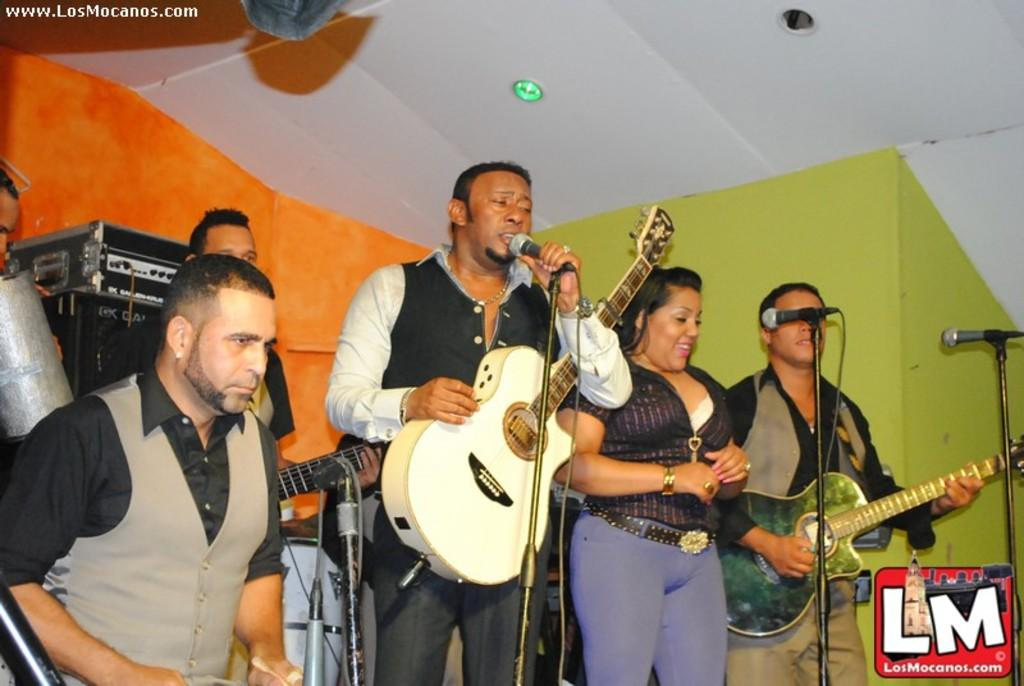What is happening on the stage in the image? There are people on the stage, and they are performing. What type of performance is taking place? The performance involves singing and playing musical instruments. Can you see a cat playing in the alley during the performance? There is no cat or alley present in the image; the focus is on the people performing on the stage. 